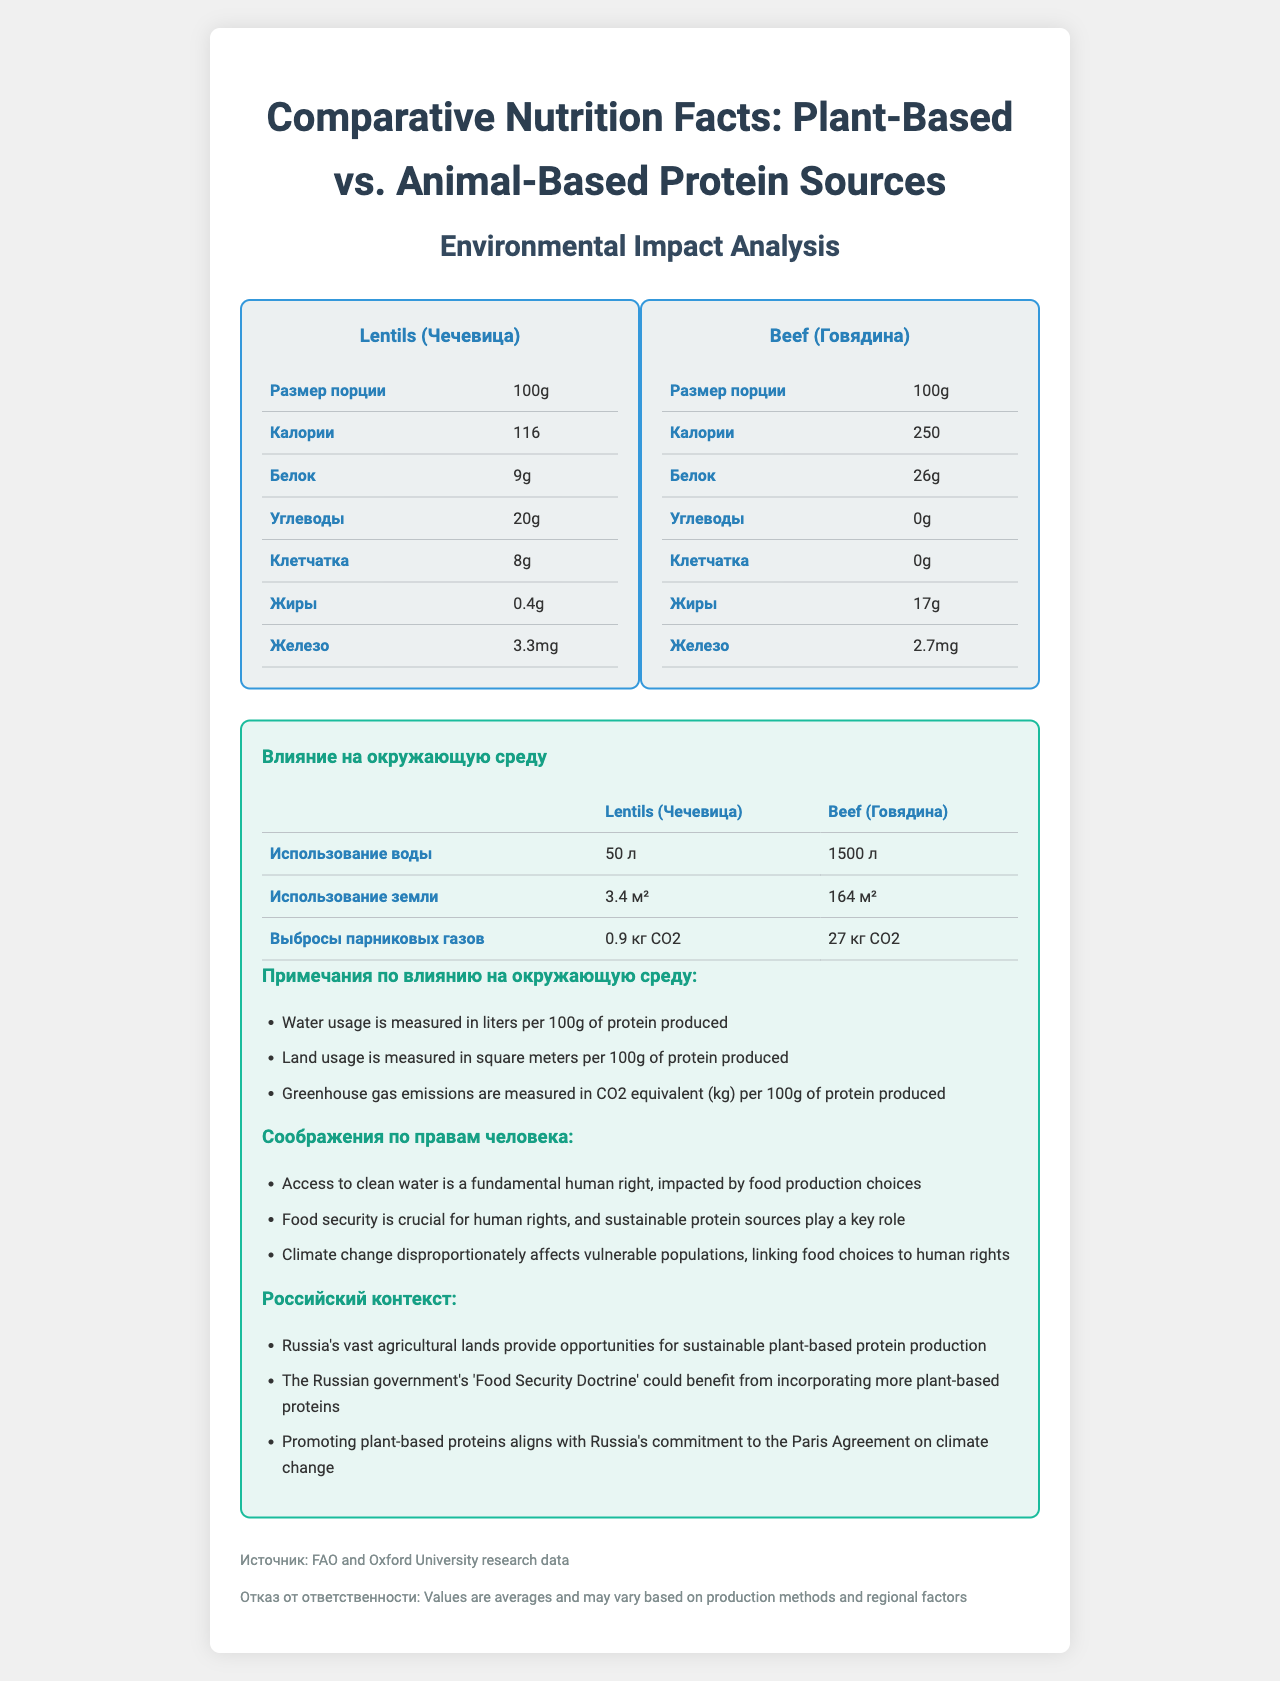what is the serving size for both protein sources? The serving size for both Lentils and Beef is mentioned as 100g in the document.
Answer: 100g which protein source has more calories per serving? Beef has 250 calories per serving compared to Lentils, which have 116 calories per serving.
Answer: Beef how much protein do lentils provide per serving? Lentils provide 9g of protein per 100g serving as shown in the nutrition label for plant-based protein.
Answer: 9g which has more iron, lentils or beef? Lentils have 3.3mg of iron per serving, while Beef has 2.7mg of iron per serving.
Answer: Lentils list the environmental impact metrics for lentils. The environmental impact row for lentils includes water usage, land usage, and greenhouse gas emissions.
Answer: 50 liters of water, 3.4 square meters of land, 0.9 kg CO2 emissions. what kind of fiber content is found in beef? According to the nutrition label for Beef, it contains 0g of fiber.
Answer: 0g which protein source uses more water? A. Lentils B. Beef Beef uses 1500 liters of water, whereas Lentils use only 50 liters.
Answer: B which protein source results in higher greenhouse gas emissions? 1. Beef 2. Lentils Beef results in 27 kg CO2 emissions compared to Lentils, which emit only 0.9 kg CO2.
Answer: 1 can the nutrition facts help identify production methods? The nutrition facts provide data on nutritional content and environmental impacts but do not include details on production methods.
Answer: No do both protein sources contain carbohydrates? Lentils contain 20g of carbohydrates, while Beef contains 0g of carbohydrates.
Answer: No describe the main idea of the document. The document provides a comprehensive comparison between Lentils and Beef in terms of calorie content, protein, carbohydrates, fiber, fat, iron, water usage, land usage, and greenhouse gas emissions, while also including human rights and Russian context considerations.
Answer: The document compares the nutrition facts and environmental impact of plant-based and animal-based protein sources. what is the fiber content in lentils? The nutrition label for Lentils shows that 100g contains 8g of fiber.
Answer: 8g 